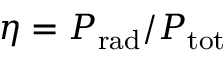<formula> <loc_0><loc_0><loc_500><loc_500>\eta = P _ { r a d } / P _ { t o t }</formula> 